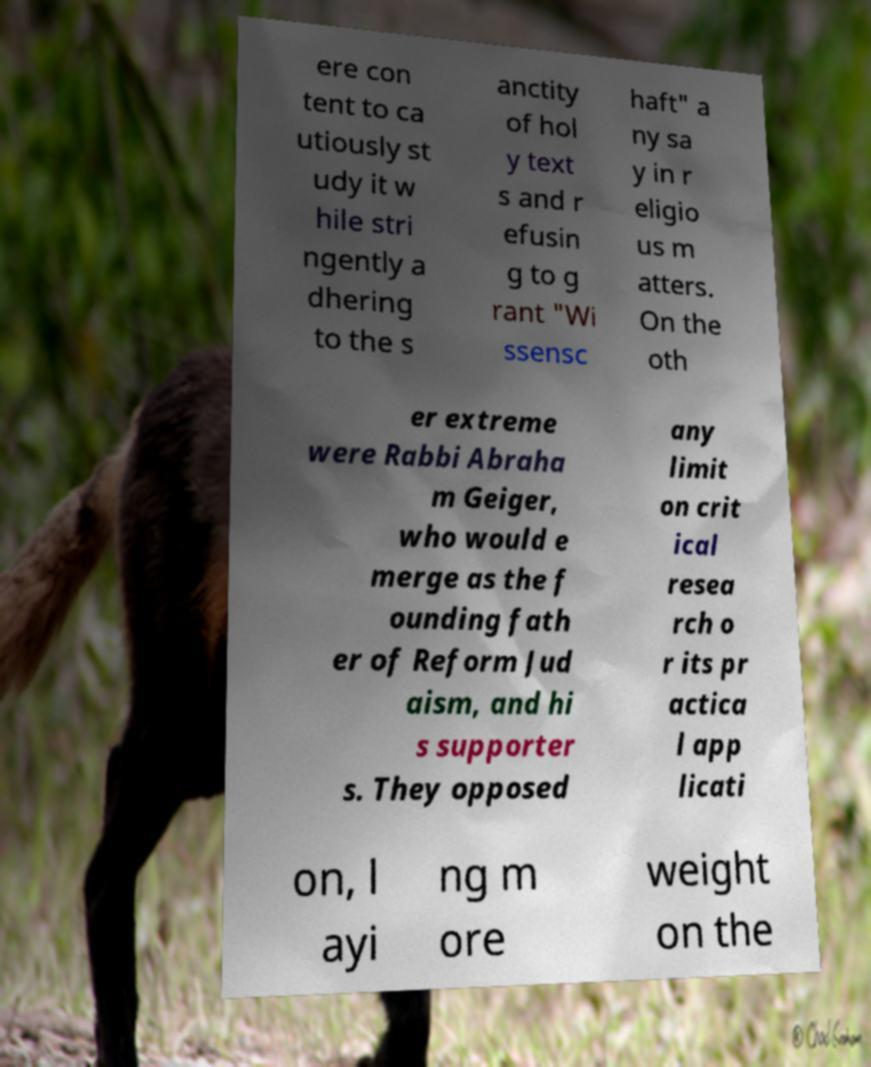There's text embedded in this image that I need extracted. Can you transcribe it verbatim? ere con tent to ca utiously st udy it w hile stri ngently a dhering to the s anctity of hol y text s and r efusin g to g rant "Wi ssensc haft" a ny sa y in r eligio us m atters. On the oth er extreme were Rabbi Abraha m Geiger, who would e merge as the f ounding fath er of Reform Jud aism, and hi s supporter s. They opposed any limit on crit ical resea rch o r its pr actica l app licati on, l ayi ng m ore weight on the 